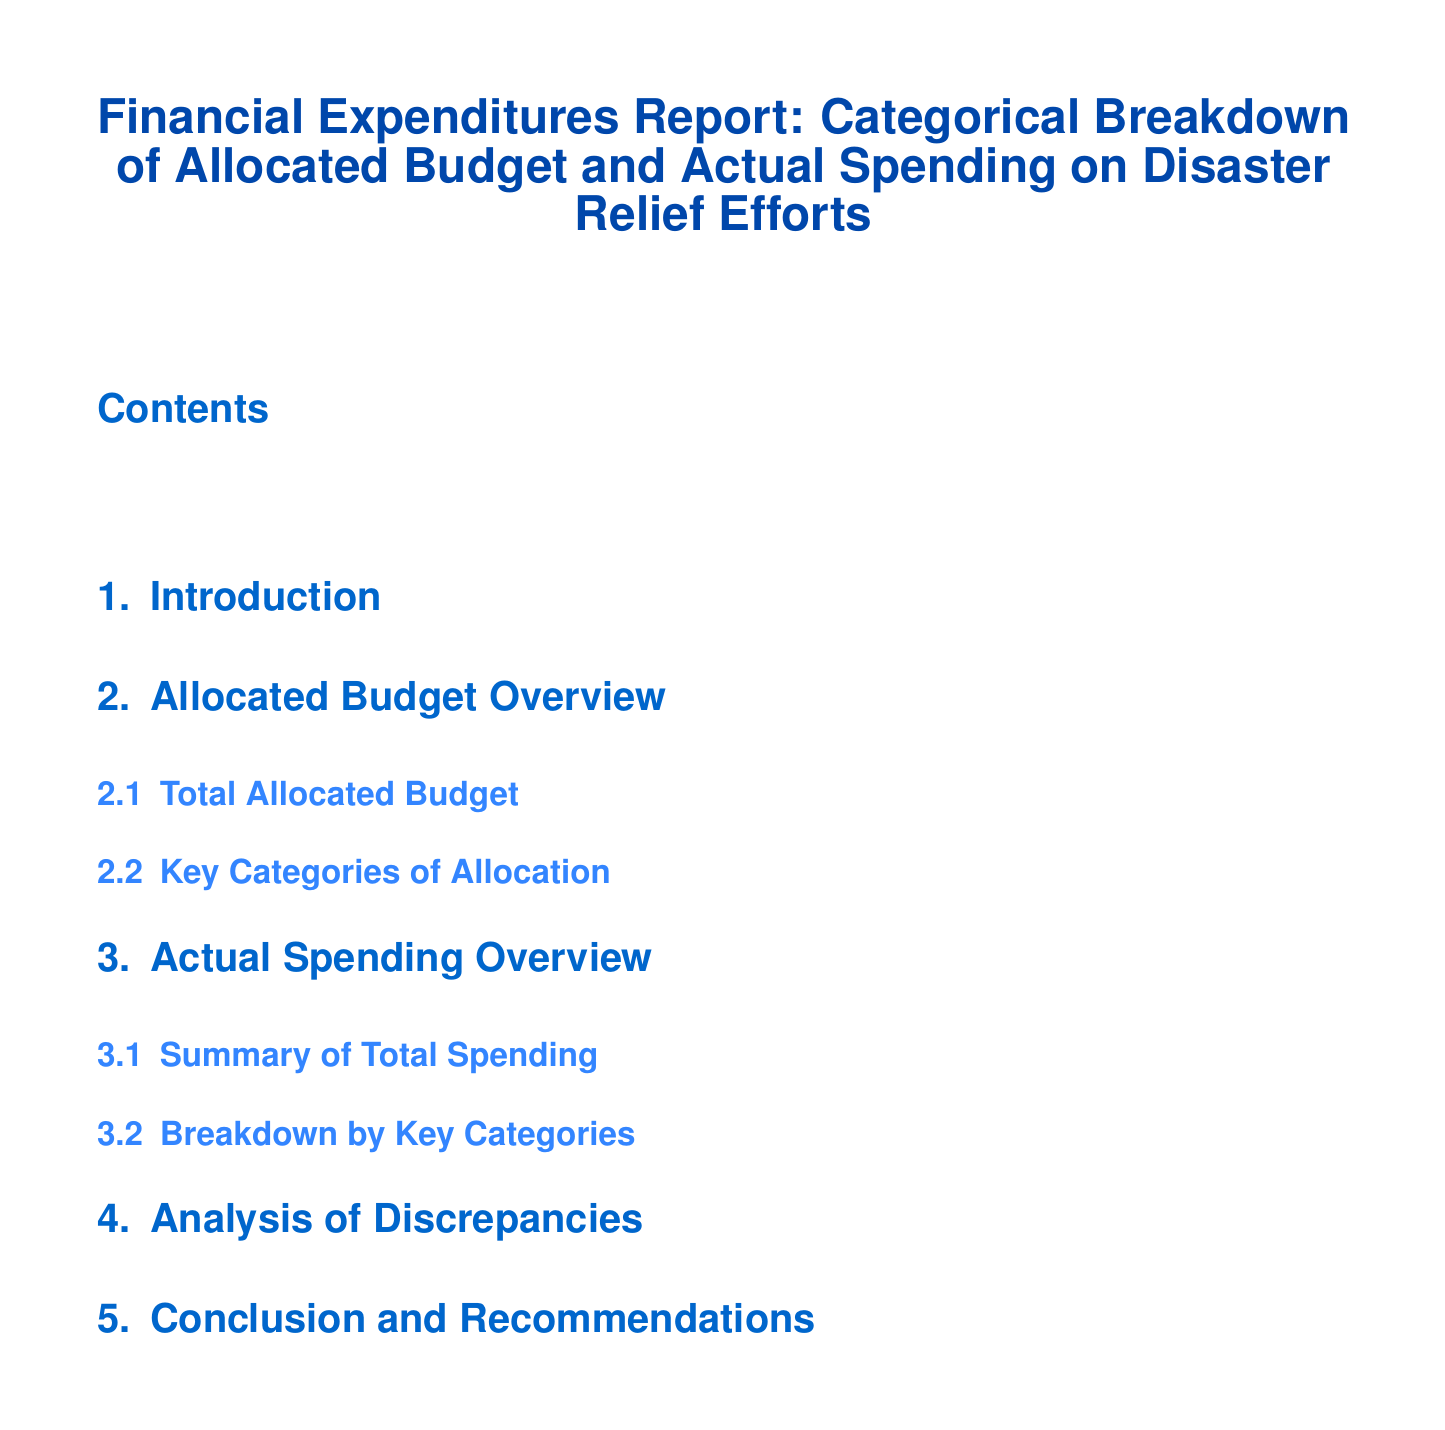what is the title of the report? The title of the report is presented prominently at the beginning of the document.
Answer: Financial Expenditures Report: Categorical Breakdown of Allocated Budget and Actual Spending on Disaster Relief Efforts how many sections are in the document? The sections of the document can be counted from the table of contents.
Answer: 6 what is included in the overview of the allocated budget? The allocated budget overview includes a total allocated budget and key categories of allocation.
Answer: Total Allocated Budget, Key Categories of Allocation what is the focus of the section on actual spending? The section on actual spending focuses on summarizing total spending and providing a breakdown by key categories.
Answer: Summary of Total Spending, Breakdown by Key Categories what is the purpose of the analysis of discrepancies section? The section aims to analyze the differences between the allocated budget and actual spending.
Answer: Analyze differences what recommendations might be included in the conclusion? The conclusion likely includes suggestions to improve future budget allocations and spending.
Answer: Improve future budget allocations and spending 